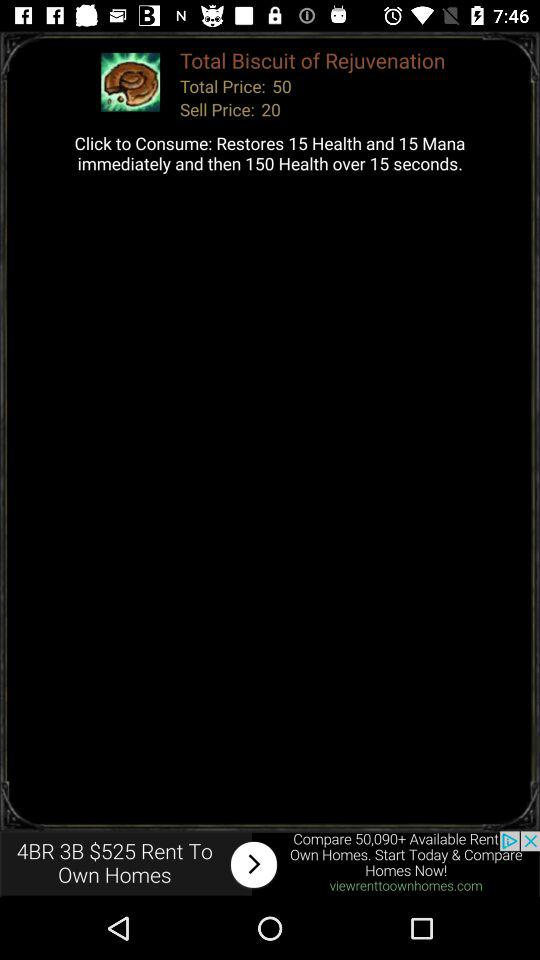Over how many seconds is 150 health restored? 150 health is restored over 15 seconds. 